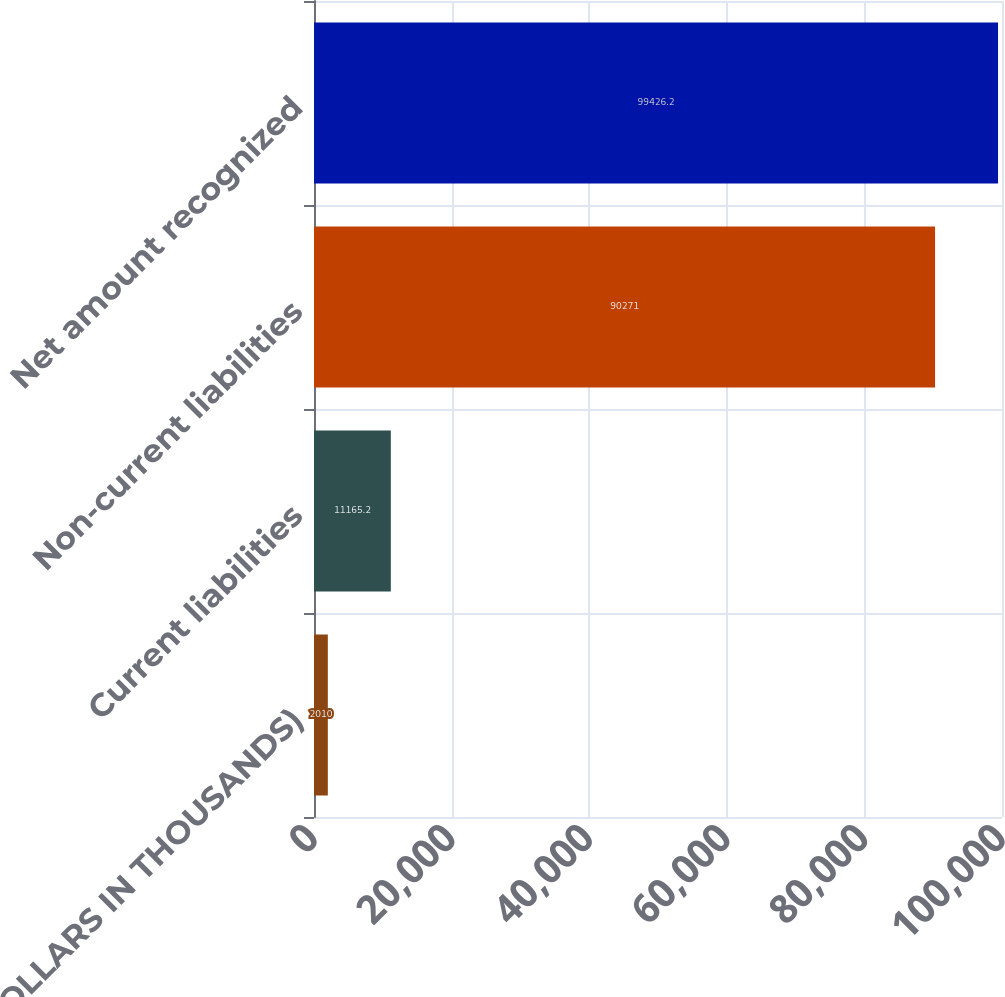<chart> <loc_0><loc_0><loc_500><loc_500><bar_chart><fcel>(DOLLARS IN THOUSANDS)<fcel>Current liabilities<fcel>Non-current liabilities<fcel>Net amount recognized<nl><fcel>2010<fcel>11165.2<fcel>90271<fcel>99426.2<nl></chart> 